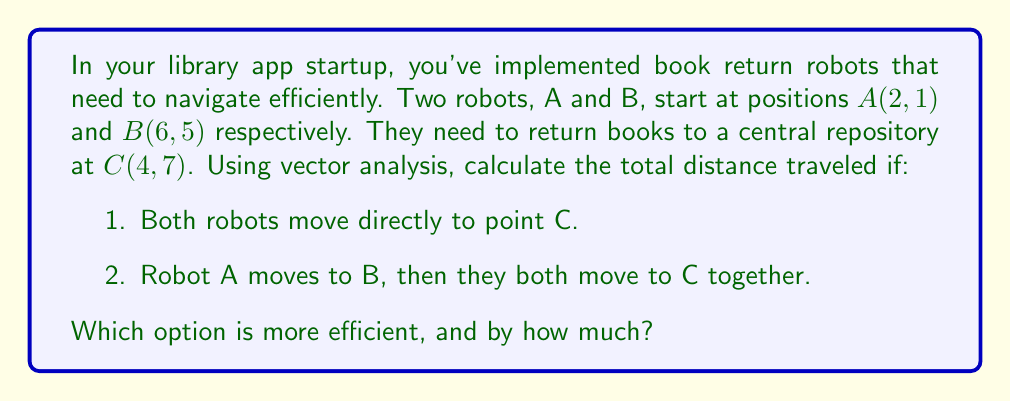Provide a solution to this math problem. Let's approach this step-by-step using vector analysis:

1. First, let's calculate the distances for option 1:

   Vector $\vec{AC} = C - A = (4-2, 7-1) = (2, 6)$
   Distance AC = $\|\vec{AC}\| = \sqrt{2^2 + 6^2} = \sqrt{40} = 2\sqrt{10}$

   Vector $\vec{BC} = C - B = (4-6, 7-5) = (-2, 2)$
   Distance BC = $\|\vec{BC}\| = \sqrt{(-2)^2 + 2^2} = \sqrt{8} = 2\sqrt{2}$

   Total distance for option 1 = $2\sqrt{10} + 2\sqrt{2}$

2. Now, let's calculate the distances for option 2:

   Vector $\vec{AB} = B - A = (6-2, 5-1) = (4, 4)$
   Distance AB = $\|\vec{AB}\| = \sqrt{4^2 + 4^2} = \sqrt{32} = 4\sqrt{2}$

   We already calculated BC: $2\sqrt{2}$

   Total distance for option 2 = $4\sqrt{2} + 2\sqrt{2} = 6\sqrt{2}$

3. To compare:
   Option 1: $2\sqrt{10} + 2\sqrt{2} \approx 9.47$ units
   Option 2: $6\sqrt{2} \approx 8.49$ units

Therefore, option 2 is more efficient. The difference is:
$(2\sqrt{10} + 2\sqrt{2}) - 6\sqrt{2} = 2\sqrt{10} - 4\sqrt{2} \approx 0.98$ units
Answer: Option 2 (Robot A moves to B, then both move to C) is more efficient by approximately 0.98 units. 